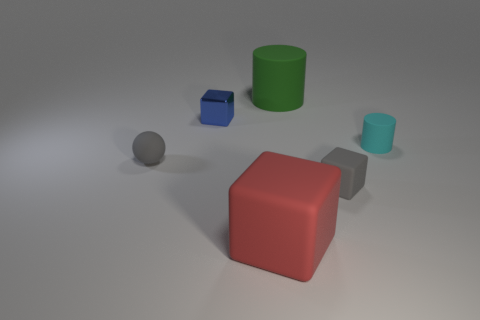What color is the tiny matte object that is the same shape as the tiny shiny object?
Your answer should be very brief. Gray. Is there any other thing that has the same shape as the tiny cyan matte thing?
Offer a very short reply. Yes. Is the number of large cylinders that are in front of the gray matte sphere the same as the number of small purple metallic things?
Your answer should be compact. Yes. There is a big red rubber object; are there any tiny cyan matte cylinders behind it?
Provide a short and direct response. Yes. What size is the gray object behind the matte block on the right side of the large thing in front of the small matte cylinder?
Ensure brevity in your answer.  Small. Does the gray matte thing to the left of the big cylinder have the same shape as the big object that is behind the tiny blue metallic block?
Provide a succinct answer. No. There is a red rubber object that is the same shape as the small blue shiny thing; what size is it?
Provide a succinct answer. Large. What number of other things are the same material as the red object?
Offer a terse response. 4. What is the material of the red object?
Provide a short and direct response. Rubber. There is a large object in front of the cylinder right of the large cylinder; what shape is it?
Provide a succinct answer. Cube. 